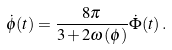<formula> <loc_0><loc_0><loc_500><loc_500>\dot { \phi } ( t ) = \frac { 8 \pi } { 3 + 2 \omega ( \phi ) } \dot { \Phi } ( t ) \, .</formula> 